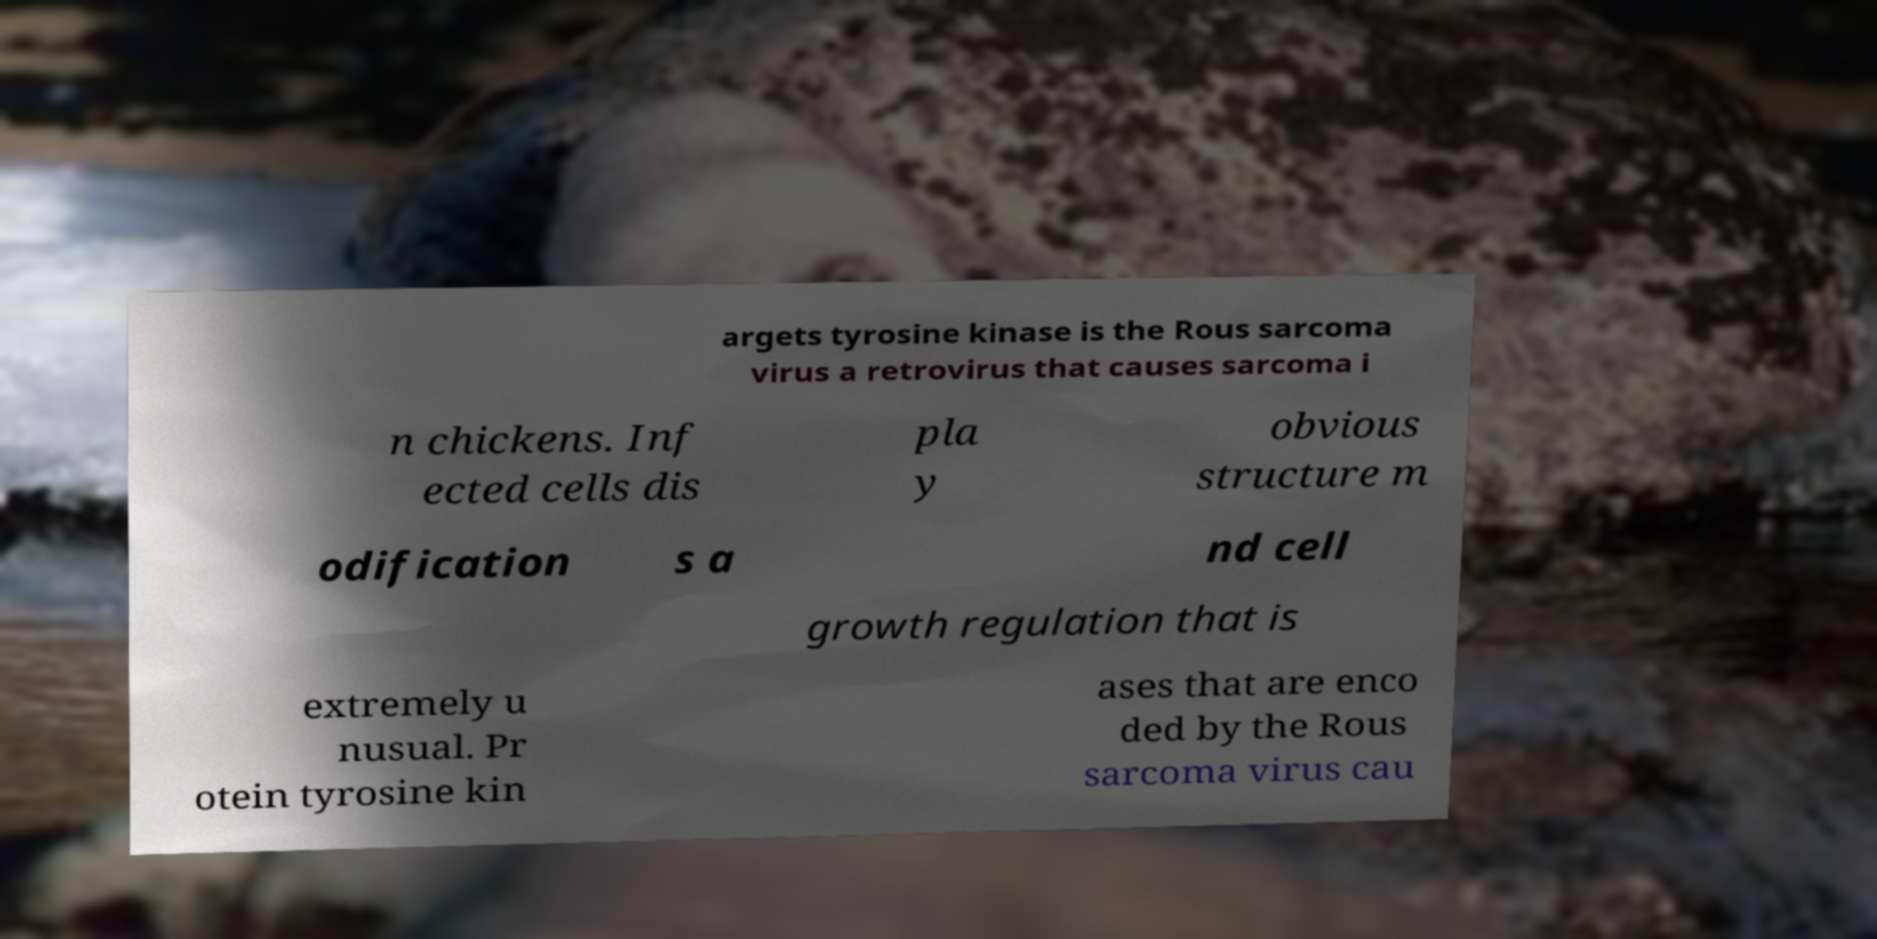I need the written content from this picture converted into text. Can you do that? argets tyrosine kinase is the Rous sarcoma virus a retrovirus that causes sarcoma i n chickens. Inf ected cells dis pla y obvious structure m odification s a nd cell growth regulation that is extremely u nusual. Pr otein tyrosine kin ases that are enco ded by the Rous sarcoma virus cau 